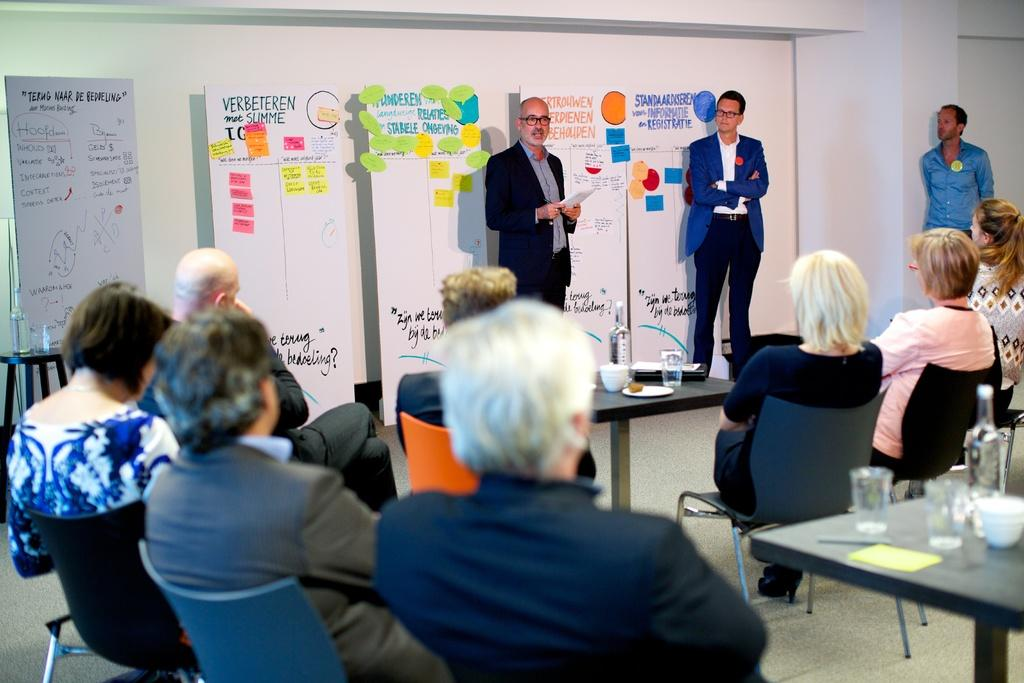What are the people in the image doing? There are people sitting on chairs in the image. Can you describe the infant in the image? Yes, there is an infant in the image. How many men are standing in the image? There are three men standing in the image. What are the men doing in the image? The men are looking at each other. Where is the lamp located in the image? There is no lamp present in the image. What part of the infant's body is visible in the image? The infant is not visible in the image, only the men and people sitting on chairs are present. 